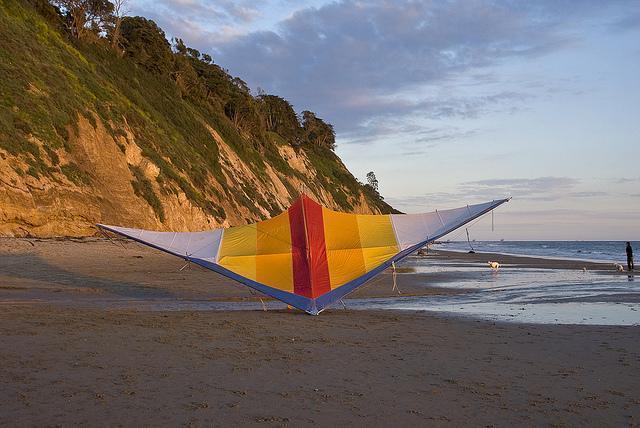What color is in the middle of the kite?
Select the accurate answer and provide explanation: 'Answer: answer
Rationale: rationale.'
Options: Red, blue, black, green. Answer: red.
Rationale: The kite has numerous colors and red is in the middle of the others. 